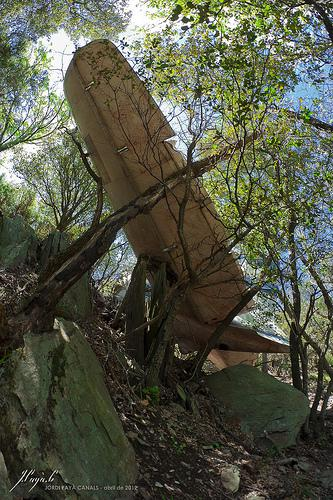Question: what season is it?
Choices:
A. Spring.
B. Summer.
C. Fall.
D. Winter.
Answer with the letter. Answer: A Question: how many people are there?
Choices:
A. None.
B. One.
C. Two.
D. Four.
Answer with the letter. Answer: A Question: what is in the sky?
Choices:
A. A plane.
B. Clouds.
C. A bird.
D. Superman.
Answer with the letter. Answer: B 